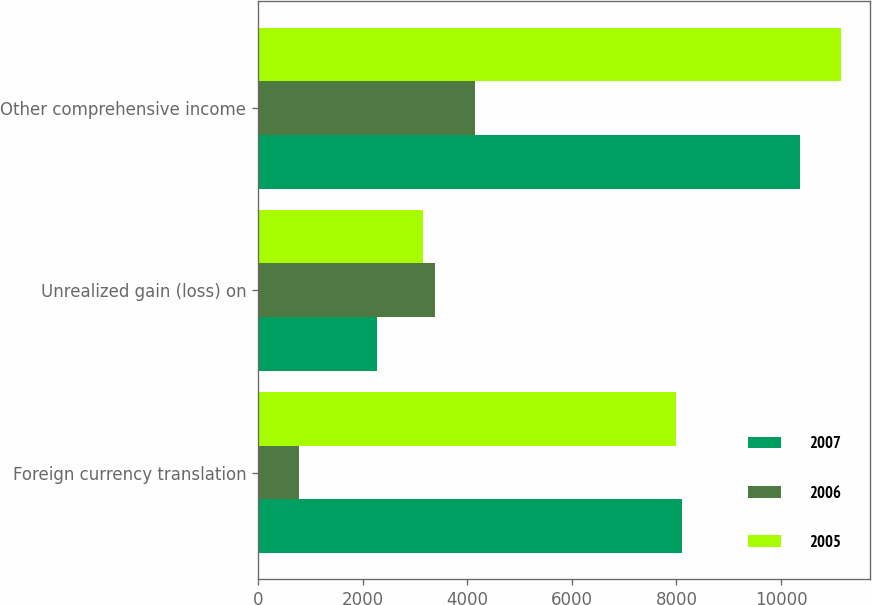Convert chart. <chart><loc_0><loc_0><loc_500><loc_500><stacked_bar_chart><ecel><fcel>Foreign currency translation<fcel>Unrealized gain (loss) on<fcel>Other comprehensive income<nl><fcel>2007<fcel>8101<fcel>2272<fcel>10373<nl><fcel>2006<fcel>776<fcel>3379<fcel>4155<nl><fcel>2005<fcel>7988<fcel>3154<fcel>11142<nl></chart> 